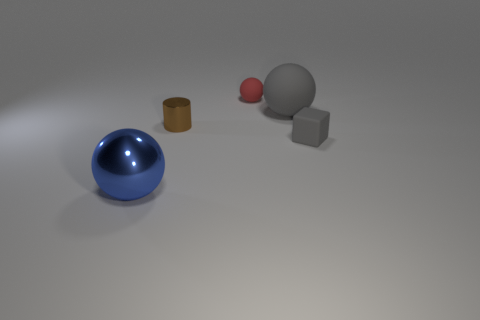There is a large metallic sphere; is it the same color as the small matte thing that is behind the cylinder?
Keep it short and to the point. No. There is a gray object that is the same size as the metallic sphere; what material is it?
Your answer should be very brief. Rubber. Is there a blue object made of the same material as the gray block?
Give a very brief answer. No. How many gray rubber cubes are there?
Your answer should be very brief. 1. Is the big gray sphere made of the same material as the ball in front of the tiny brown metallic cylinder?
Make the answer very short. No. There is a tiny object that is the same color as the big rubber sphere; what material is it?
Your answer should be very brief. Rubber. How many big matte balls have the same color as the rubber block?
Provide a succinct answer. 1. What is the size of the red sphere?
Offer a terse response. Small. Do the large matte object and the small rubber thing to the left of the big matte sphere have the same shape?
Provide a succinct answer. Yes. What color is the small ball that is the same material as the small gray object?
Your answer should be compact. Red. 